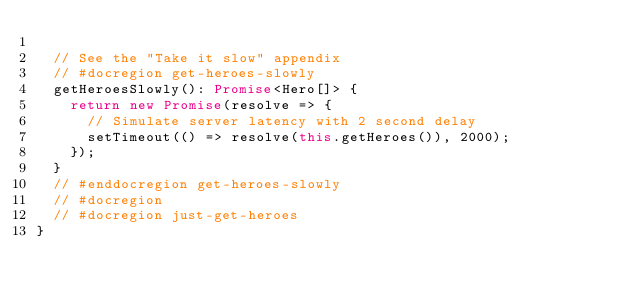<code> <loc_0><loc_0><loc_500><loc_500><_TypeScript_>
  // See the "Take it slow" appendix
  // #docregion get-heroes-slowly
  getHeroesSlowly(): Promise<Hero[]> {
    return new Promise(resolve => {
      // Simulate server latency with 2 second delay
      setTimeout(() => resolve(this.getHeroes()), 2000);
    });
  }
  // #enddocregion get-heroes-slowly
  // #docregion
  // #docregion just-get-heroes
}
</code> 